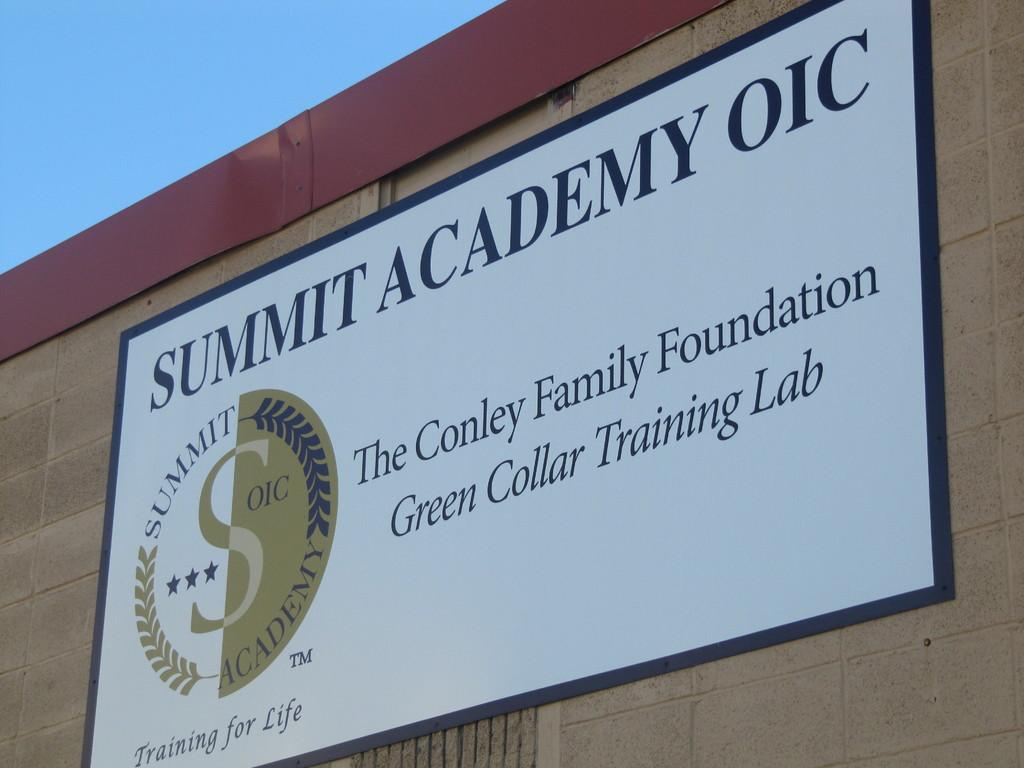<image>
Share a concise interpretation of the image provided. A sign on a building that says Summit Academy OIC. 